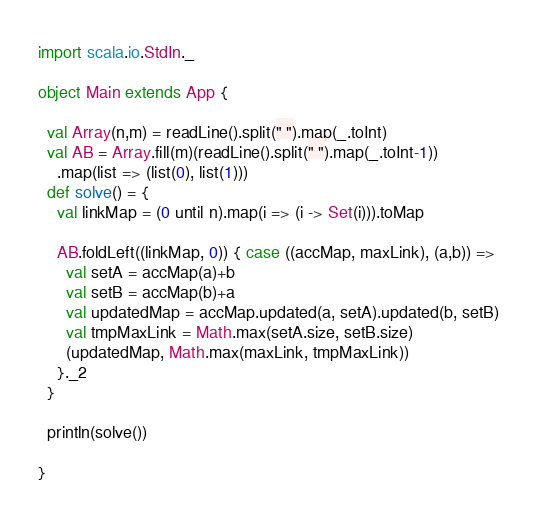Convert code to text. <code><loc_0><loc_0><loc_500><loc_500><_Scala_>import scala.io.StdIn._

object Main extends App {

  val Array(n,m) = readLine().split(" ").map(_.toInt)
  val AB = Array.fill(m)(readLine().split(" ").map(_.toInt-1))
    .map(list => (list(0), list(1)))
  def solve() = {
    val linkMap = (0 until n).map(i => (i -> Set(i))).toMap

    AB.foldLeft((linkMap, 0)) { case ((accMap, maxLink), (a,b)) =>
      val setA = accMap(a)+b
      val setB = accMap(b)+a
      val updatedMap = accMap.updated(a, setA).updated(b, setB)
      val tmpMaxLink = Math.max(setA.size, setB.size)
      (updatedMap, Math.max(maxLink, tmpMaxLink))
    }._2
  }

  println(solve())

}

</code> 